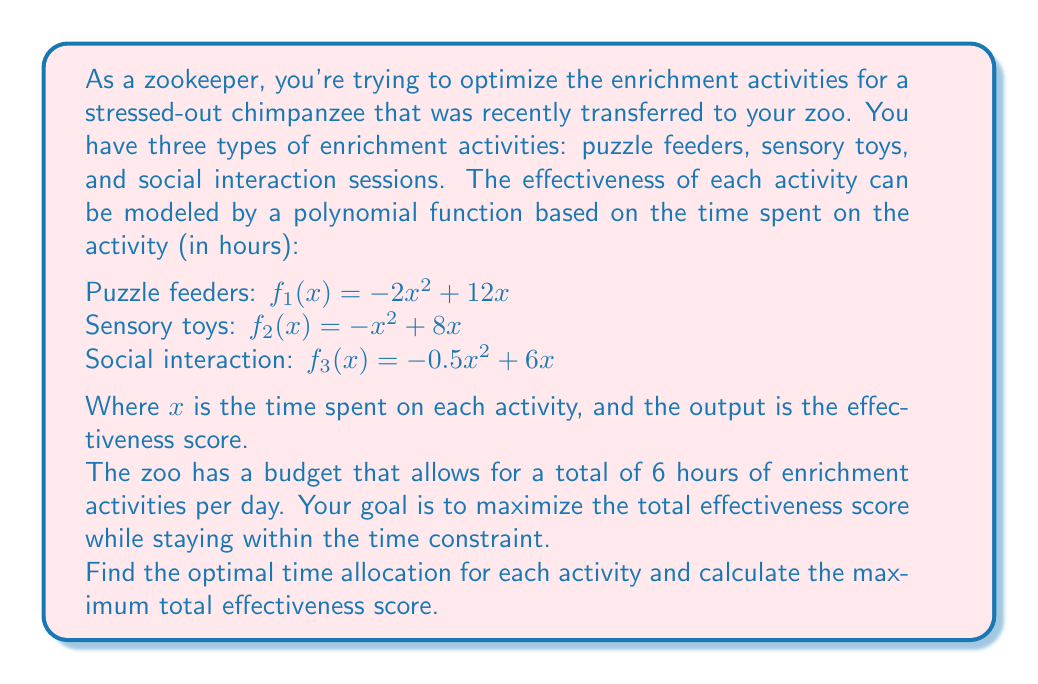Provide a solution to this math problem. To solve this optimization problem, we'll use the method of Lagrange multipliers, which is ideal for constrained optimization problems involving polynomials.

1) First, let's define our objective function and constraint:

   Objective function: $F(x_1, x_2, x_3) = f_1(x_1) + f_2(x_2) + f_3(x_3)$
   $= (-2x_1^2 + 12x_1) + (-x_2^2 + 8x_2) + (-0.5x_3^2 + 6x_3)$

   Constraint: $g(x_1, x_2, x_3) = x_1 + x_2 + x_3 - 6 = 0$

2) Now, we form the Lagrangian function:
   $L(x_1, x_2, x_3, \lambda) = F(x_1, x_2, x_3) - \lambda g(x_1, x_2, x_3)$

3) We take partial derivatives and set them equal to zero:

   $\frac{\partial L}{\partial x_1} = -4x_1 + 12 - \lambda = 0$
   $\frac{\partial L}{\partial x_2} = -2x_2 + 8 - \lambda = 0$
   $\frac{\partial L}{\partial x_3} = -x_3 + 6 - \lambda = 0$
   $\frac{\partial L}{\partial \lambda} = x_1 + x_2 + x_3 - 6 = 0$

4) From these equations, we can derive:
   $x_1 = 3 - \frac{\lambda}{4}$
   $x_2 = 4 - \frac{\lambda}{2}$
   $x_3 = 6 - \lambda$

5) Substituting these into the constraint equation:
   $(3 - \frac{\lambda}{4}) + (4 - \frac{\lambda}{2}) + (6 - \lambda) = 6$
   $13 - \frac{\lambda}{4} - \frac{\lambda}{2} - \lambda = 6$
   $13 - \frac{7\lambda}{4} = 6$
   $7 = \frac{7\lambda}{4}$
   $\lambda = 4$

6) Now we can solve for $x_1$, $x_2$, and $x_3$:
   $x_1 = 3 - \frac{4}{4} = 2$
   $x_2 = 4 - \frac{4}{2} = 2$
   $x_3 = 6 - 4 = 2$

7) To find the maximum effectiveness score, we substitute these values into our original objective function:

   $F(2, 2, 2) = (-2(2)^2 + 12(2)) + (-(2)^2 + 8(2)) + (-0.5(2)^2 + 6(2))$
                $= (16) + (12) + (10)$
                $= 38$

Therefore, the optimal time allocation is 2 hours for each activity, resulting in a maximum effectiveness score of 38.
Answer: The optimal time allocation is 2 hours for each activity (puzzle feeders, sensory toys, and social interaction). The maximum total effectiveness score is 38. 